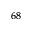<formula> <loc_0><loc_0><loc_500><loc_500>^ { 6 8 }</formula> 